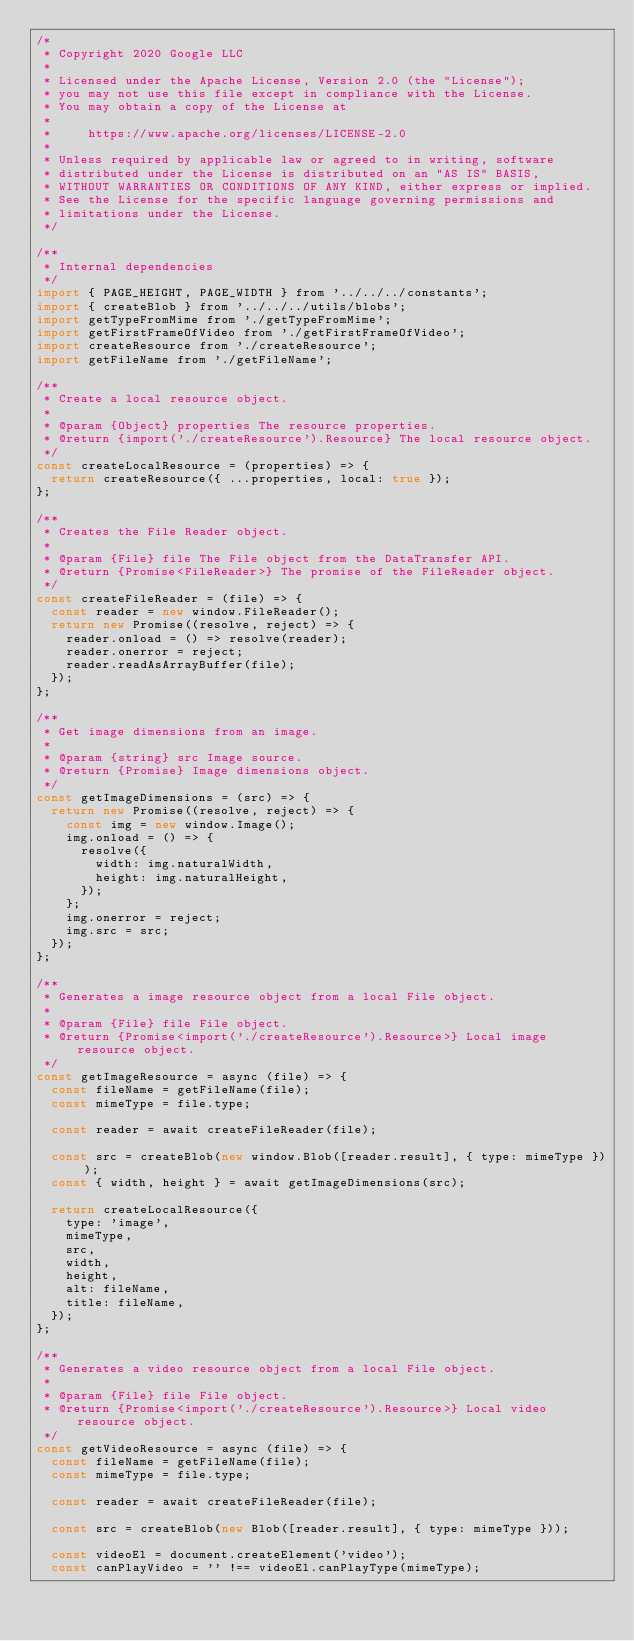<code> <loc_0><loc_0><loc_500><loc_500><_JavaScript_>/*
 * Copyright 2020 Google LLC
 *
 * Licensed under the Apache License, Version 2.0 (the "License");
 * you may not use this file except in compliance with the License.
 * You may obtain a copy of the License at
 *
 *     https://www.apache.org/licenses/LICENSE-2.0
 *
 * Unless required by applicable law or agreed to in writing, software
 * distributed under the License is distributed on an "AS IS" BASIS,
 * WITHOUT WARRANTIES OR CONDITIONS OF ANY KIND, either express or implied.
 * See the License for the specific language governing permissions and
 * limitations under the License.
 */

/**
 * Internal dependencies
 */
import { PAGE_HEIGHT, PAGE_WIDTH } from '../../../constants';
import { createBlob } from '../../../utils/blobs';
import getTypeFromMime from './getTypeFromMime';
import getFirstFrameOfVideo from './getFirstFrameOfVideo';
import createResource from './createResource';
import getFileName from './getFileName';

/**
 * Create a local resource object.
 *
 * @param {Object} properties The resource properties.
 * @return {import('./createResource').Resource} The local resource object.
 */
const createLocalResource = (properties) => {
  return createResource({ ...properties, local: true });
};

/**
 * Creates the File Reader object.
 *
 * @param {File} file The File object from the DataTransfer API.
 * @return {Promise<FileReader>} The promise of the FileReader object.
 */
const createFileReader = (file) => {
  const reader = new window.FileReader();
  return new Promise((resolve, reject) => {
    reader.onload = () => resolve(reader);
    reader.onerror = reject;
    reader.readAsArrayBuffer(file);
  });
};

/**
 * Get image dimensions from an image.
 *
 * @param {string} src Image source.
 * @return {Promise} Image dimensions object.
 */
const getImageDimensions = (src) => {
  return new Promise((resolve, reject) => {
    const img = new window.Image();
    img.onload = () => {
      resolve({
        width: img.naturalWidth,
        height: img.naturalHeight,
      });
    };
    img.onerror = reject;
    img.src = src;
  });
};

/**
 * Generates a image resource object from a local File object.
 *
 * @param {File} file File object.
 * @return {Promise<import('./createResource').Resource>} Local image resource object.
 */
const getImageResource = async (file) => {
  const fileName = getFileName(file);
  const mimeType = file.type;

  const reader = await createFileReader(file);

  const src = createBlob(new window.Blob([reader.result], { type: mimeType }));
  const { width, height } = await getImageDimensions(src);

  return createLocalResource({
    type: 'image',
    mimeType,
    src,
    width,
    height,
    alt: fileName,
    title: fileName,
  });
};

/**
 * Generates a video resource object from a local File object.
 *
 * @param {File} file File object.
 * @return {Promise<import('./createResource').Resource>} Local video resource object.
 */
const getVideoResource = async (file) => {
  const fileName = getFileName(file);
  const mimeType = file.type;

  const reader = await createFileReader(file);

  const src = createBlob(new Blob([reader.result], { type: mimeType }));

  const videoEl = document.createElement('video');
  const canPlayVideo = '' !== videoEl.canPlayType(mimeType);
</code> 